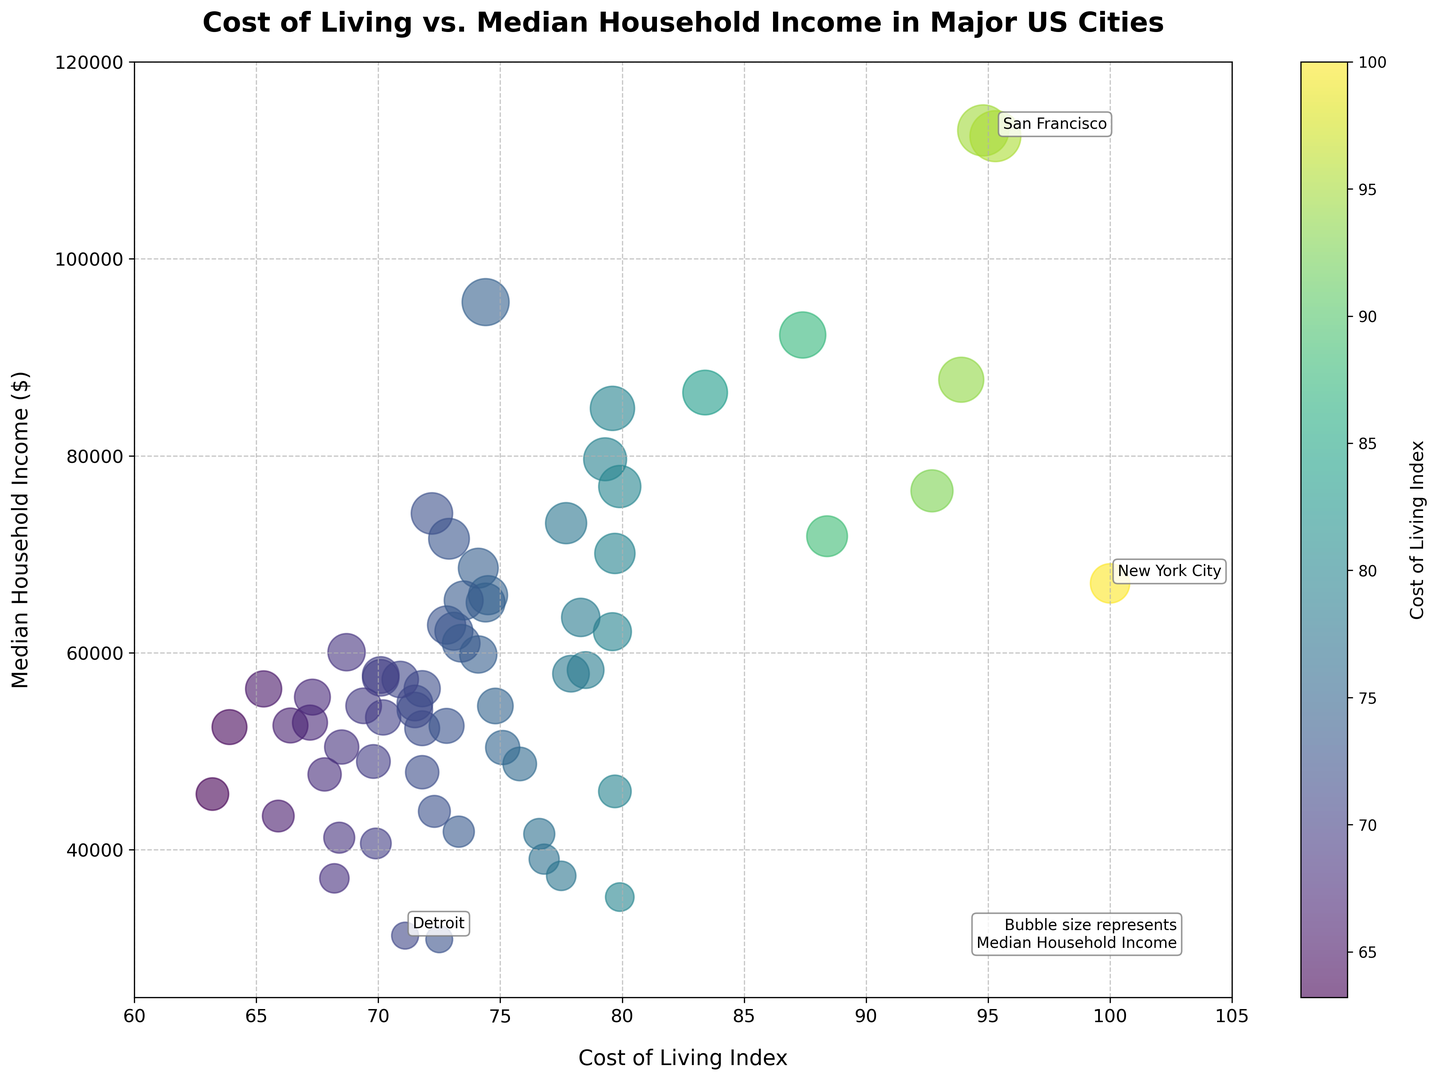Which city has the highest median household income? By examining the bubble representing each city, the largest bubble indicates the city with the highest median household income. San Jose has the largest bubble size.
Answer: San Jose Which city has the highest cost of living index? The city with the highest cost of living index will be positioned furthest to the right on the x-axis. New York City is placed to the far right.
Answer: New York City Among New York City, San Francisco, and Detroit, which city has the lowest median household income? To determine this, compare the vertical positions (y-axis) of the bubbles labeled New York City, San Francisco, and Detroit. Detroit is positioned lowest on the y-axis.
Answer: Detroit Which cities are annotated on the plot? Annotations are added with text labels on some of the bubbles. The annotated cities are New York City, San Francisco, and Detroit.
Answer: New York City, San Francisco, Detroit Which city has a higher cost of living index, Seattle or Boston? Comparing their positions on the x-axis, Seattle is to the left of Boston indicating that Boston has a higher cost of living index.
Answer: Boston Is there a noticeable relationship between cost of living index and median household income? Observing the distribution of the bubbles, generally, higher cost of living index (rightward position) correlates with higher median household income (higher vertical position).
Answer: Yes What's the difference in median household income between the cities with the highest and lowest cost of living indices? New York City has the highest cost of living index with a median household income of 67,046, and El Paso has the lowest with a median household income of 45,656. The difference is 67,046 - 45,656.
Answer: 21,390 Which city has a higher median household income, Washington DC or Honolulu? Comparing the vertical position of Washington DC and Honolulu bubbles, Honolulu is slightly higher on the y-axis.
Answer: Honolulu Are there more cities with a cost of living index above or below 80? Count the number of bubbles left and right of the 80 mark on the x-axis. There are more cities positioned to the left (below 80) than to the right (above 80).
Answer: Below 80 